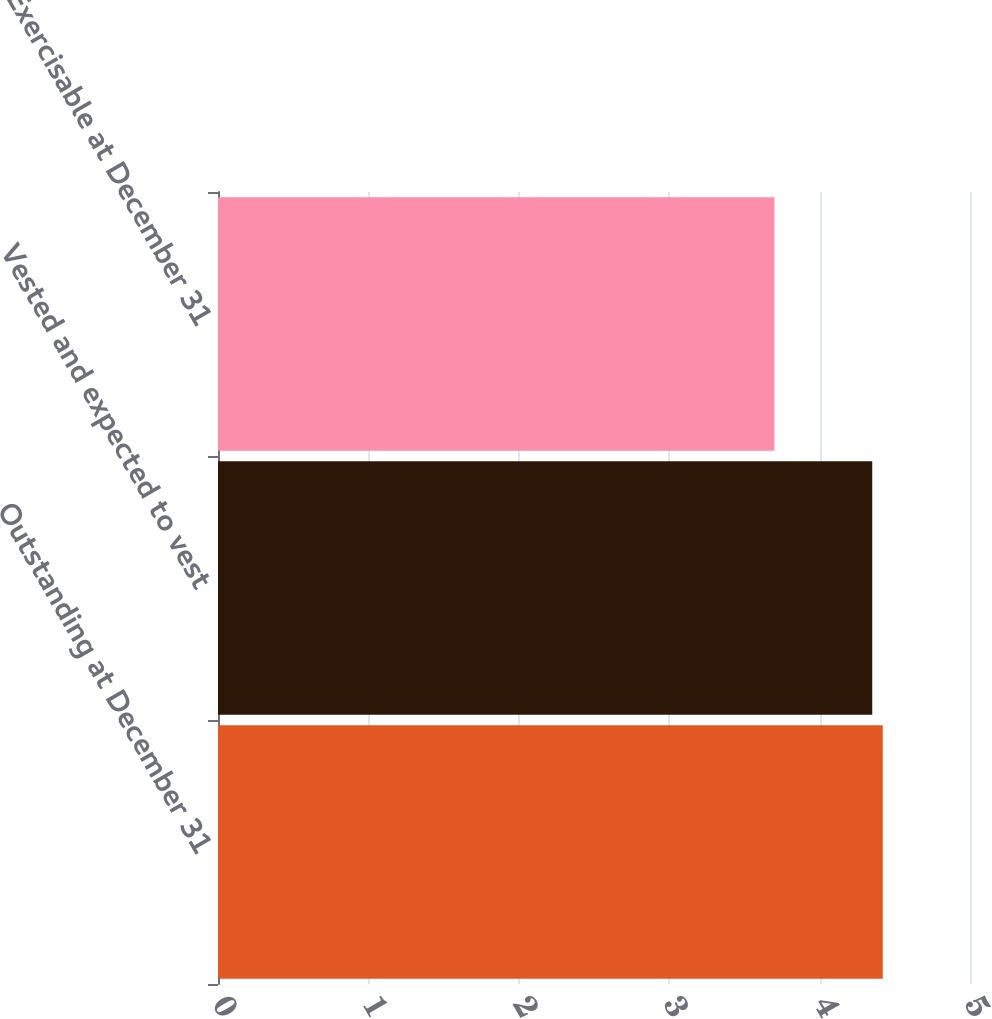Convert chart to OTSL. <chart><loc_0><loc_0><loc_500><loc_500><bar_chart><fcel>Outstanding at December 31<fcel>Vested and expected to vest<fcel>Exercisable at December 31<nl><fcel>4.42<fcel>4.35<fcel>3.7<nl></chart> 